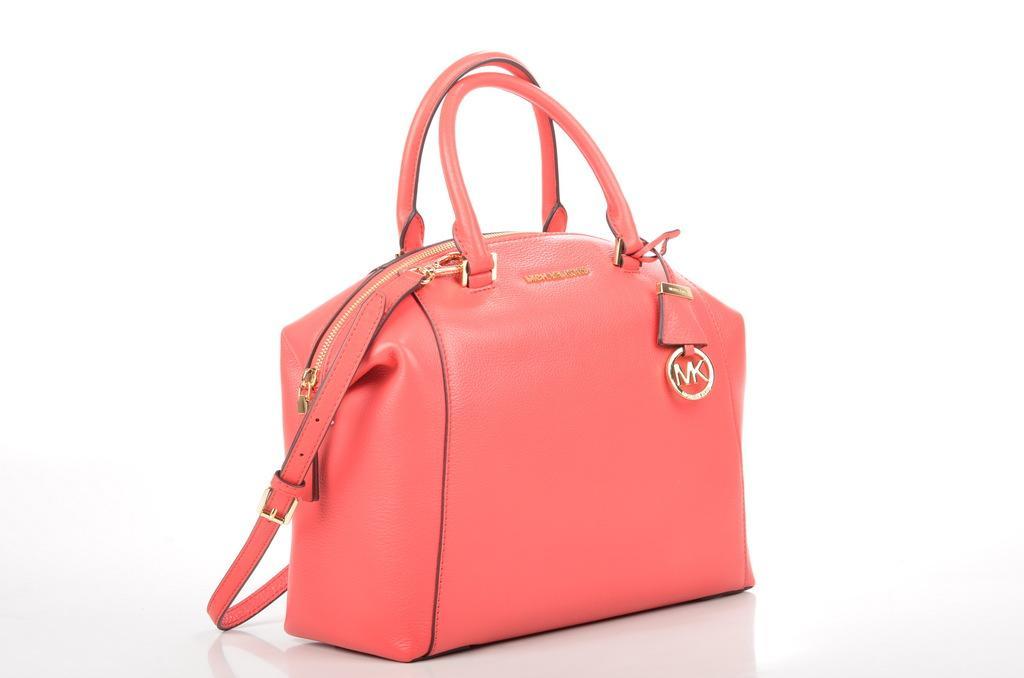Please provide a concise description of this image. This picture shows pink color handbag placed on the floor. There is a white background here. 